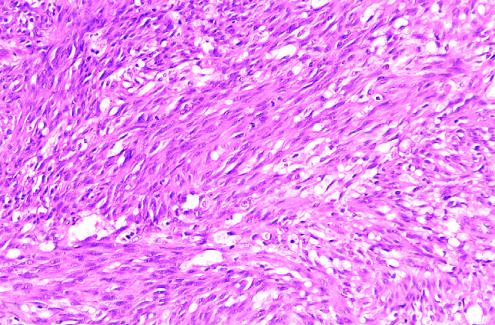did periodic acid-schiff demonstrate sheets of plump, proliferating spindle cells and slitlike vascular spaces?
Answer the question using a single word or phrase. No 